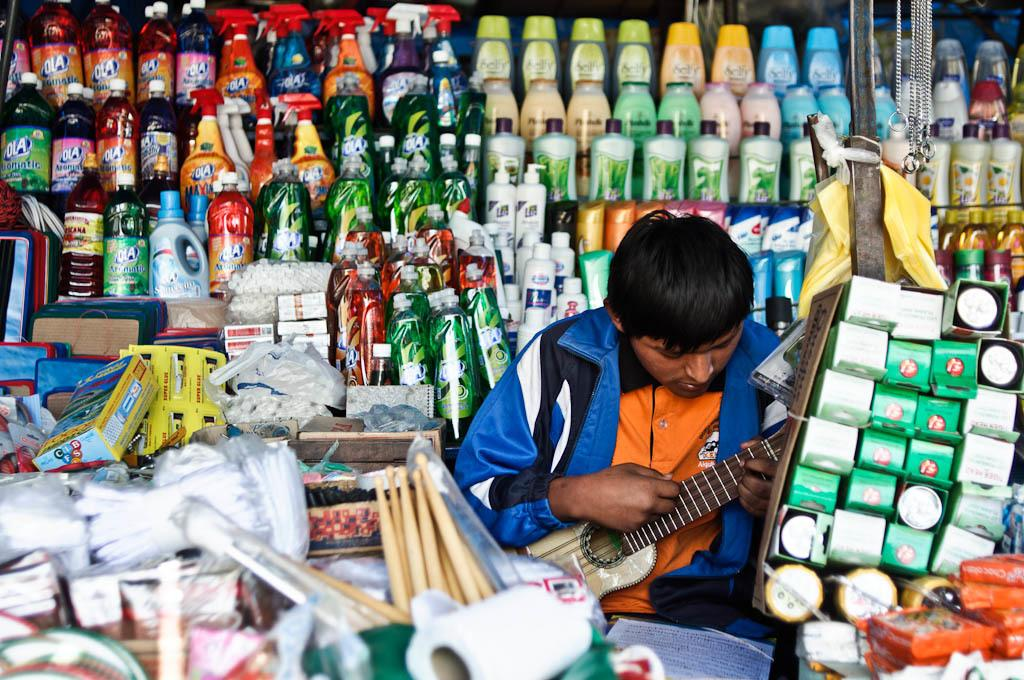Who is the main subject in the image? There is a man in the image. What is the man doing in the image? The man is sitting in the image. What is the man holding in the image? The man is holding a guitar in the image. What is the man wearing in the image? The man is wearing a blue coat in the image. What type of cheese is the man eating in the image? There is no cheese present in the image; the man is holding a guitar. Is the man wearing a mask in the image? There is no mention of a mask in the image; the man is wearing a blue coat. 